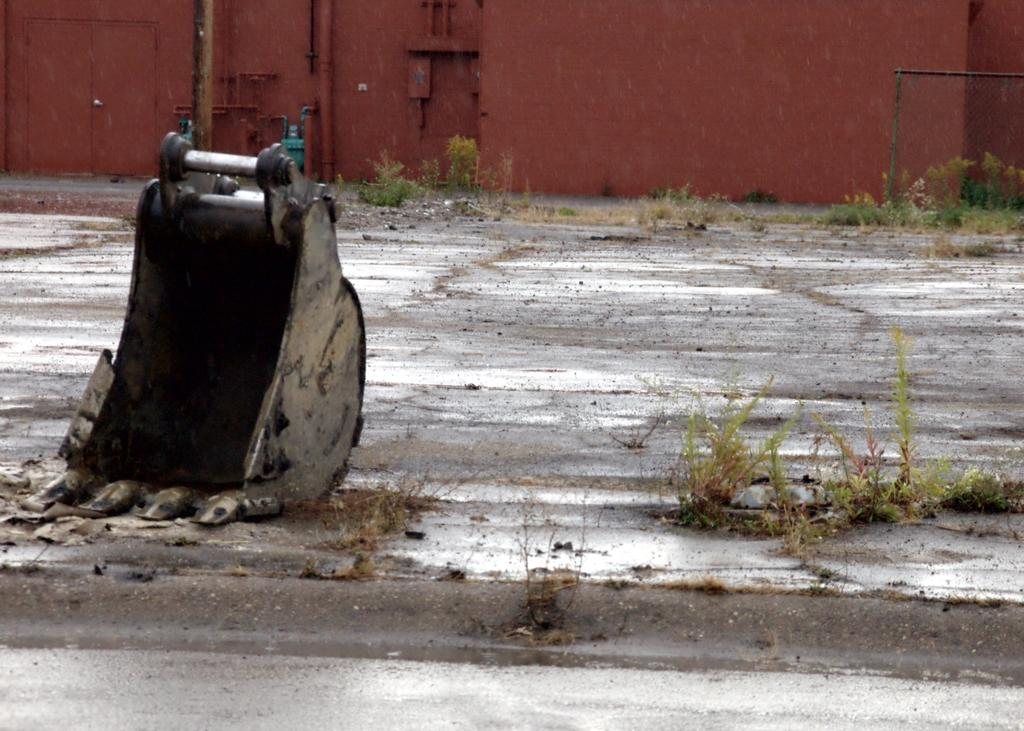Where was the image taken? The image was taken outdoors. What can be seen at the bottom of the image? There is a ground at the bottom of the image. What is visible in the background of the image? There is a wall in the background of the image. What type of machinery is present in the image? There is a part of a crane on the left side of the image. How many beds are visible in the image? There are no beds present in the image. What year was the image taken? The provided facts do not include information about the year the image was taken. 